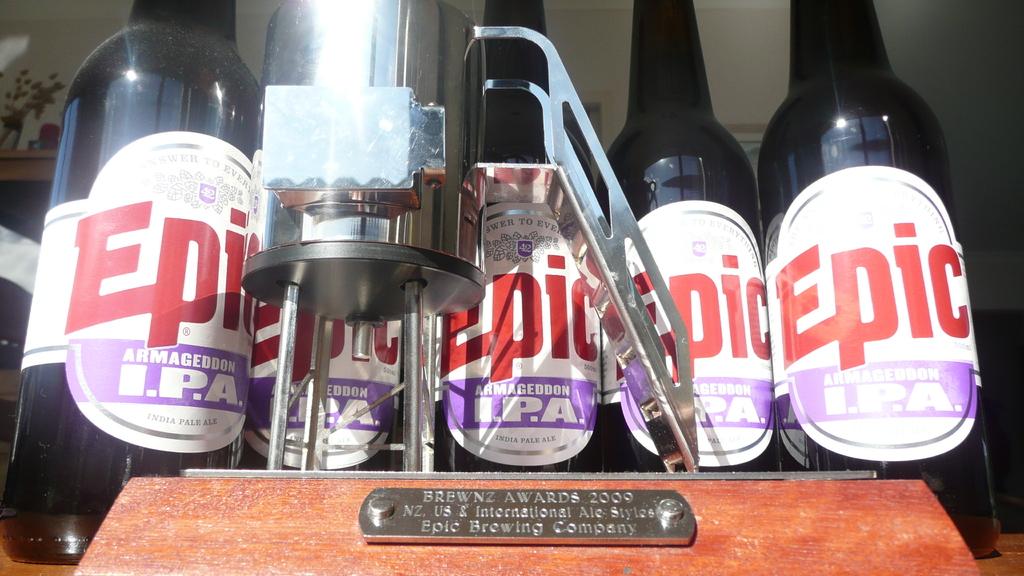What kind of beer is in the bottle?
Provide a short and direct response. Epic. 